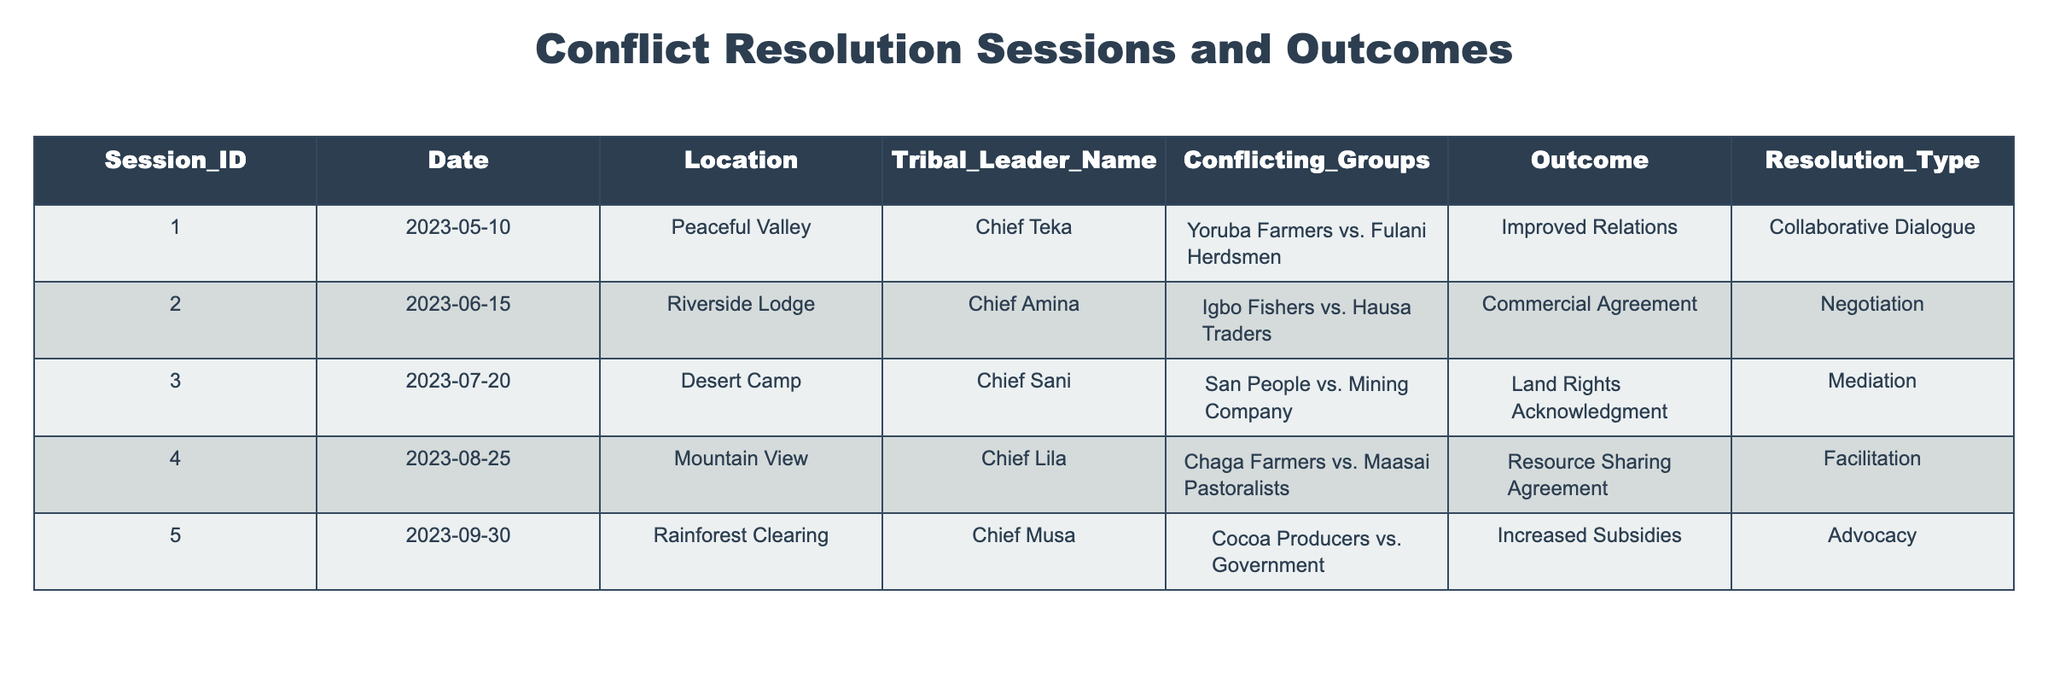What was the outcome of the session held in Peaceful Valley? The session held in Peaceful Valley was led by Chief Teka and involved the Yoruba Farmers and Fulani Herdsmen. The outcome of this session was improved relations.
Answer: Improved Relations How many sessions involved negotiation as a resolution type? There is one session that involved negotiation as a resolution type, which is the session at Riverside Lodge led by Chief Amina.
Answer: 1 Did Chief Musa lead a session that resulted in increased subsidies? Yes, Chief Musa led a session at Rainforest Clearing that resulted in increased subsidies for the cocoa producers.
Answer: Yes Which conflicting groups had a resource sharing agreement as an outcome? The conflicting groups that had a resource sharing agreement were the Chaga Farmers and the Maasai Pastoralists, discussed in a session led by Chief Lila at Mountain View.
Answer: Chaga Farmers vs. Maasai Pastoralists What is the difference in sessions between the first and last in the table? The first session in the table is about the Yoruba Farmers vs. Fulani Herdsmen, and the last session is about Cocoa Producers vs. Government. There are 4 sessions in between, making a total of 5 sessions overall. The difference in their IDs is 5 - 1 = 4.
Answer: 4 How many sessions took place in 2023 before September? The table shows sessions that took place on May 10, June 15, July 20, and August 25. That accounts for a total of 4 sessions before September.
Answer: 4 Is it true that at least one of the sessions resulted in land rights acknowledgment? Yes, it is true. The session led by Chief Sani at Desert Camp resulted in land rights acknowledgment for the San People versus the Mining Company.
Answer: Yes Which resolution type was the most common in the table? By analyzing the table, we can see that 'Negotiation,' 'Mediation,' 'Facilitation,' 'Advocacy,' and 'Collaborative Dialogue' are all represented. However, 'Advocacy' appears only once while others appear once as well, making them all equally common with one occurrence each.
Answer: All are equally common 